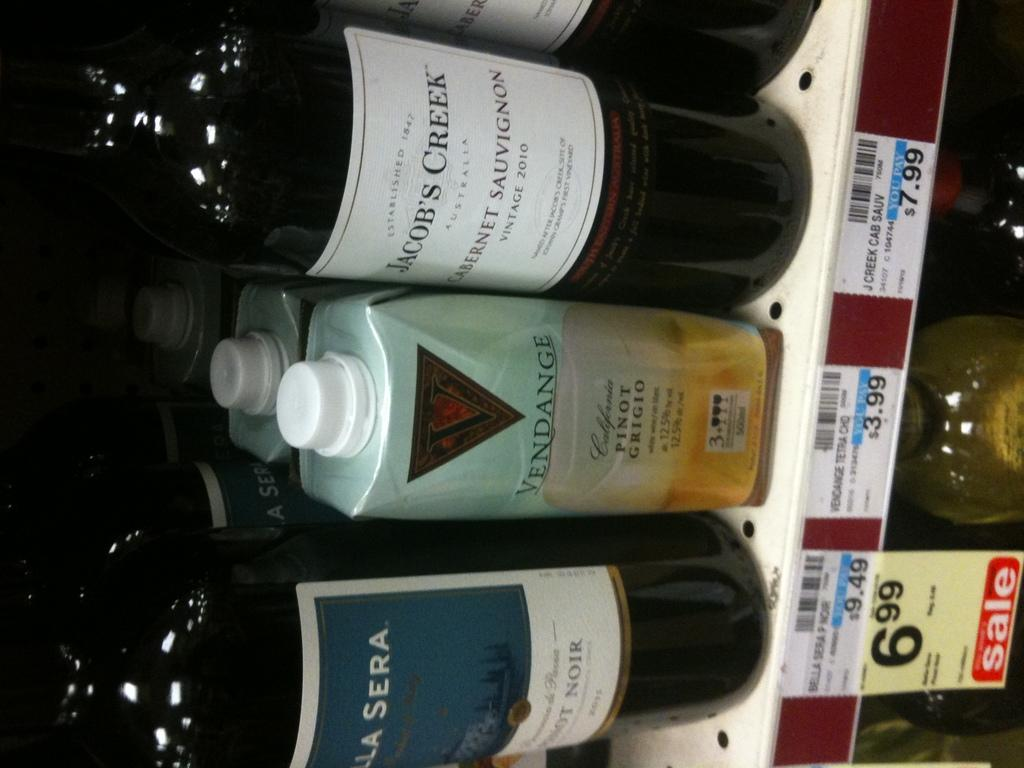<image>
Offer a succinct explanation of the picture presented. A strange looking bottle of Vendange Pinot Grigio sits between a bottle of Cabernet and a bottle of Pinot Noir. 